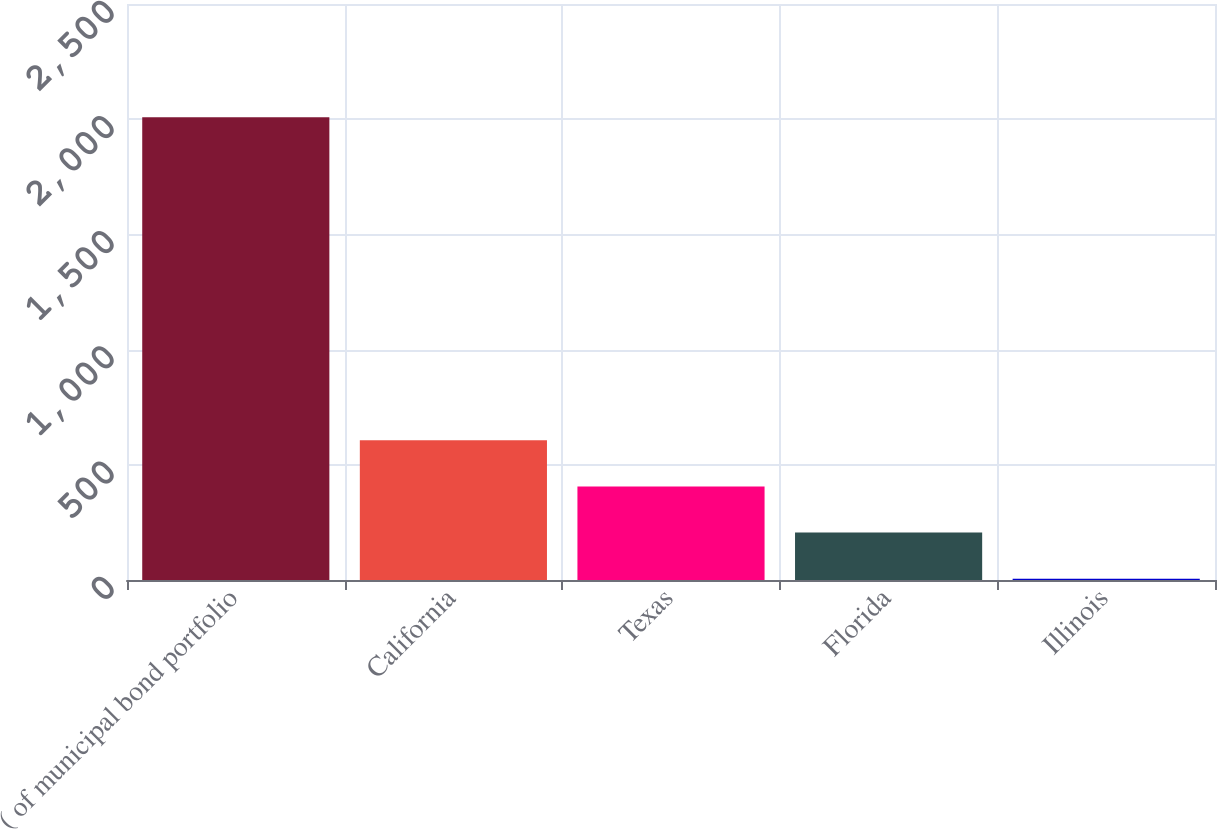<chart> <loc_0><loc_0><loc_500><loc_500><bar_chart><fcel>( of municipal bond portfolio<fcel>California<fcel>Texas<fcel>Florida<fcel>Illinois<nl><fcel>2009<fcel>606.41<fcel>406.04<fcel>205.67<fcel>5.3<nl></chart> 